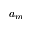<formula> <loc_0><loc_0><loc_500><loc_500>a _ { m }</formula> 